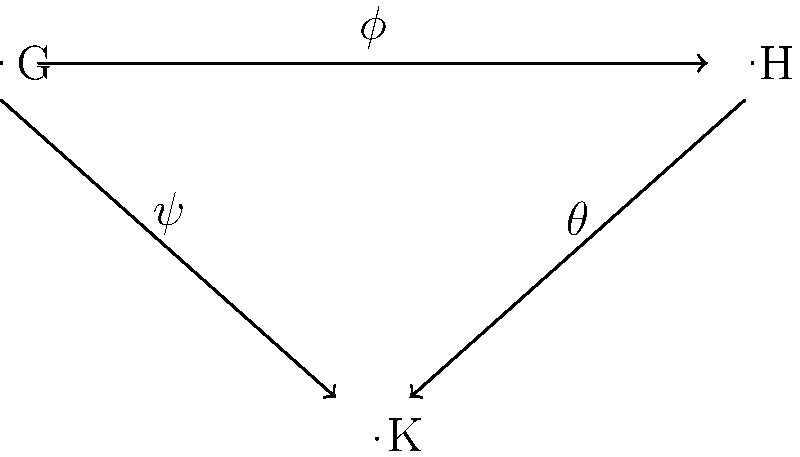In the context of political alliance formations, consider three political groups G, H, and K represented as mathematical groups. Group homomorphisms $\phi: G \rightarrow H$, $\psi: G \rightarrow K$, and $\theta: H \rightarrow K$ are shown in the diagram. If $\ker(\phi) \subseteq \ker(\psi)$, what can we conclude about the existence of a homomorphism $\rho: H \rightarrow K$ such that $\rho \circ \phi = \psi$? How might this relate to the formation of political alliances? To solve this problem, we'll follow these steps:

1. Recall the First Isomorphism Theorem: For a group homomorphism $f: G \rightarrow H$, we have $G/\ker(f) \cong \operatorname{im}(f)$.

2. Given: $\ker(\phi) \subseteq \ker(\psi)$

3. Consider the map $\bar{\psi}: G/\ker(\phi) \rightarrow K$ defined by $\bar{\psi}(g\ker(\phi)) = \psi(g)$. This is well-defined because $\ker(\phi) \subseteq \ker(\psi)$.

4. By the First Isomorphism Theorem, we know that $G/\ker(\phi) \cong \operatorname{im}(\phi)$.

5. Therefore, we can define $\rho: \operatorname{im}(\phi) \rightarrow K$ by $\rho(h) = \bar{\psi}(\bar{h})$, where $\bar{h}$ is any element in $G/\ker(\phi)$ that maps to $h$ under the isomorphism.

6. Extend $\rho$ to all of $H$ by defining it arbitrarily on elements outside $\operatorname{im}(\phi)$.

7. By construction, $\rho \circ \phi = \psi$.

In the context of political alliances, this result suggests that if the core supporters of group G who align with H (represented by $\ker(\phi)$) are also aligned with K (represented by $\ker(\psi)$), then any alliance between G and H can be extended to include K without contradicting the existing alliance between G and K. This could facilitate the formation of broader, more inclusive political coalitions.
Answer: Yes, a homomorphism $\rho: H \rightarrow K$ exists such that $\rho \circ \phi = \psi$. 